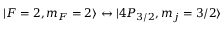<formula> <loc_0><loc_0><loc_500><loc_500>| F = 2 , m _ { F } = 2 \rangle \leftrightarrow | 4 P _ { 3 / 2 } , m _ { j } = 3 / 2 \rangle</formula> 